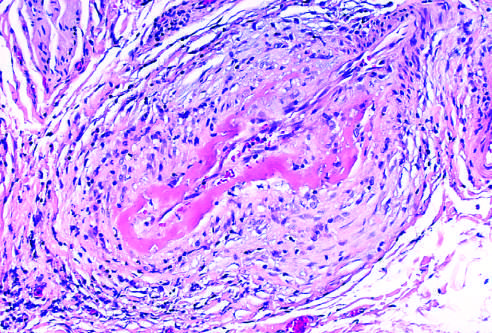s mycobacterium avium infection in a duodenal biopsy from a patient with aids uninvolved?
Answer the question using a single word or phrase. No 